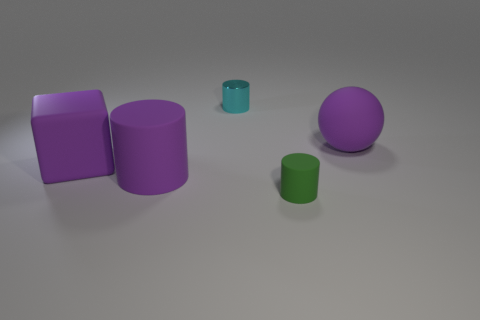Do the rubber block and the purple rubber cylinder have the same size?
Offer a very short reply. Yes. There is a big object that is in front of the large purple matte block that is to the left of the thing that is to the right of the small green cylinder; what is its material?
Offer a very short reply. Rubber. Are there an equal number of small cyan shiny objects that are to the left of the purple cylinder and large purple metallic blocks?
Your response must be concise. Yes. What number of objects are either big rubber blocks or small cyan cylinders?
Your answer should be very brief. 2. There is a tiny green thing that is made of the same material as the ball; what shape is it?
Keep it short and to the point. Cylinder. What is the size of the cylinder that is to the right of the object behind the big purple matte sphere?
Give a very brief answer. Small. What number of big objects are either green rubber cylinders or cyan cylinders?
Offer a very short reply. 0. How many other objects are there of the same color as the large rubber block?
Your response must be concise. 2. There is a matte cylinder in front of the large purple matte cylinder; is its size the same as the purple cylinder on the left side of the cyan metal object?
Your answer should be very brief. No. Is the purple sphere made of the same material as the tiny cylinder in front of the rubber cube?
Your response must be concise. Yes. 